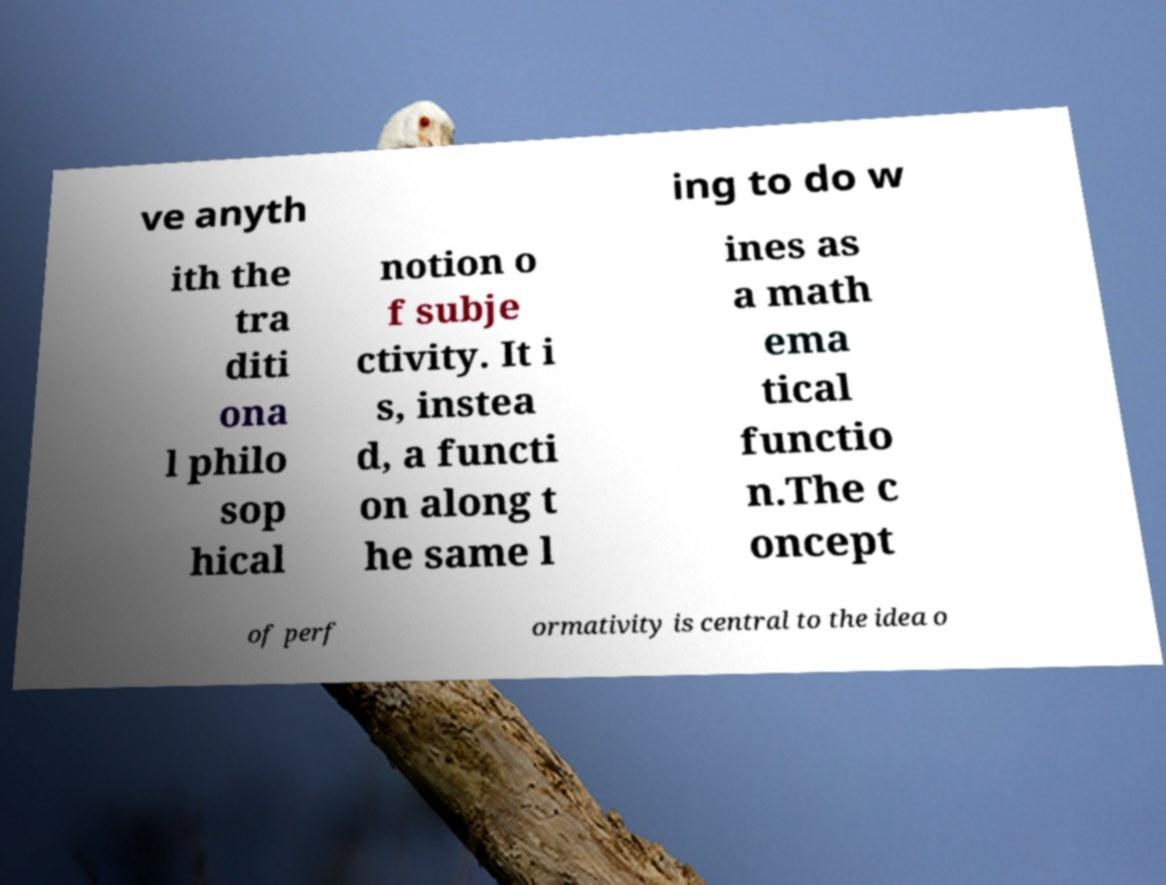Please identify and transcribe the text found in this image. ve anyth ing to do w ith the tra diti ona l philo sop hical notion o f subje ctivity. It i s, instea d, a functi on along t he same l ines as a math ema tical functio n.The c oncept of perf ormativity is central to the idea o 